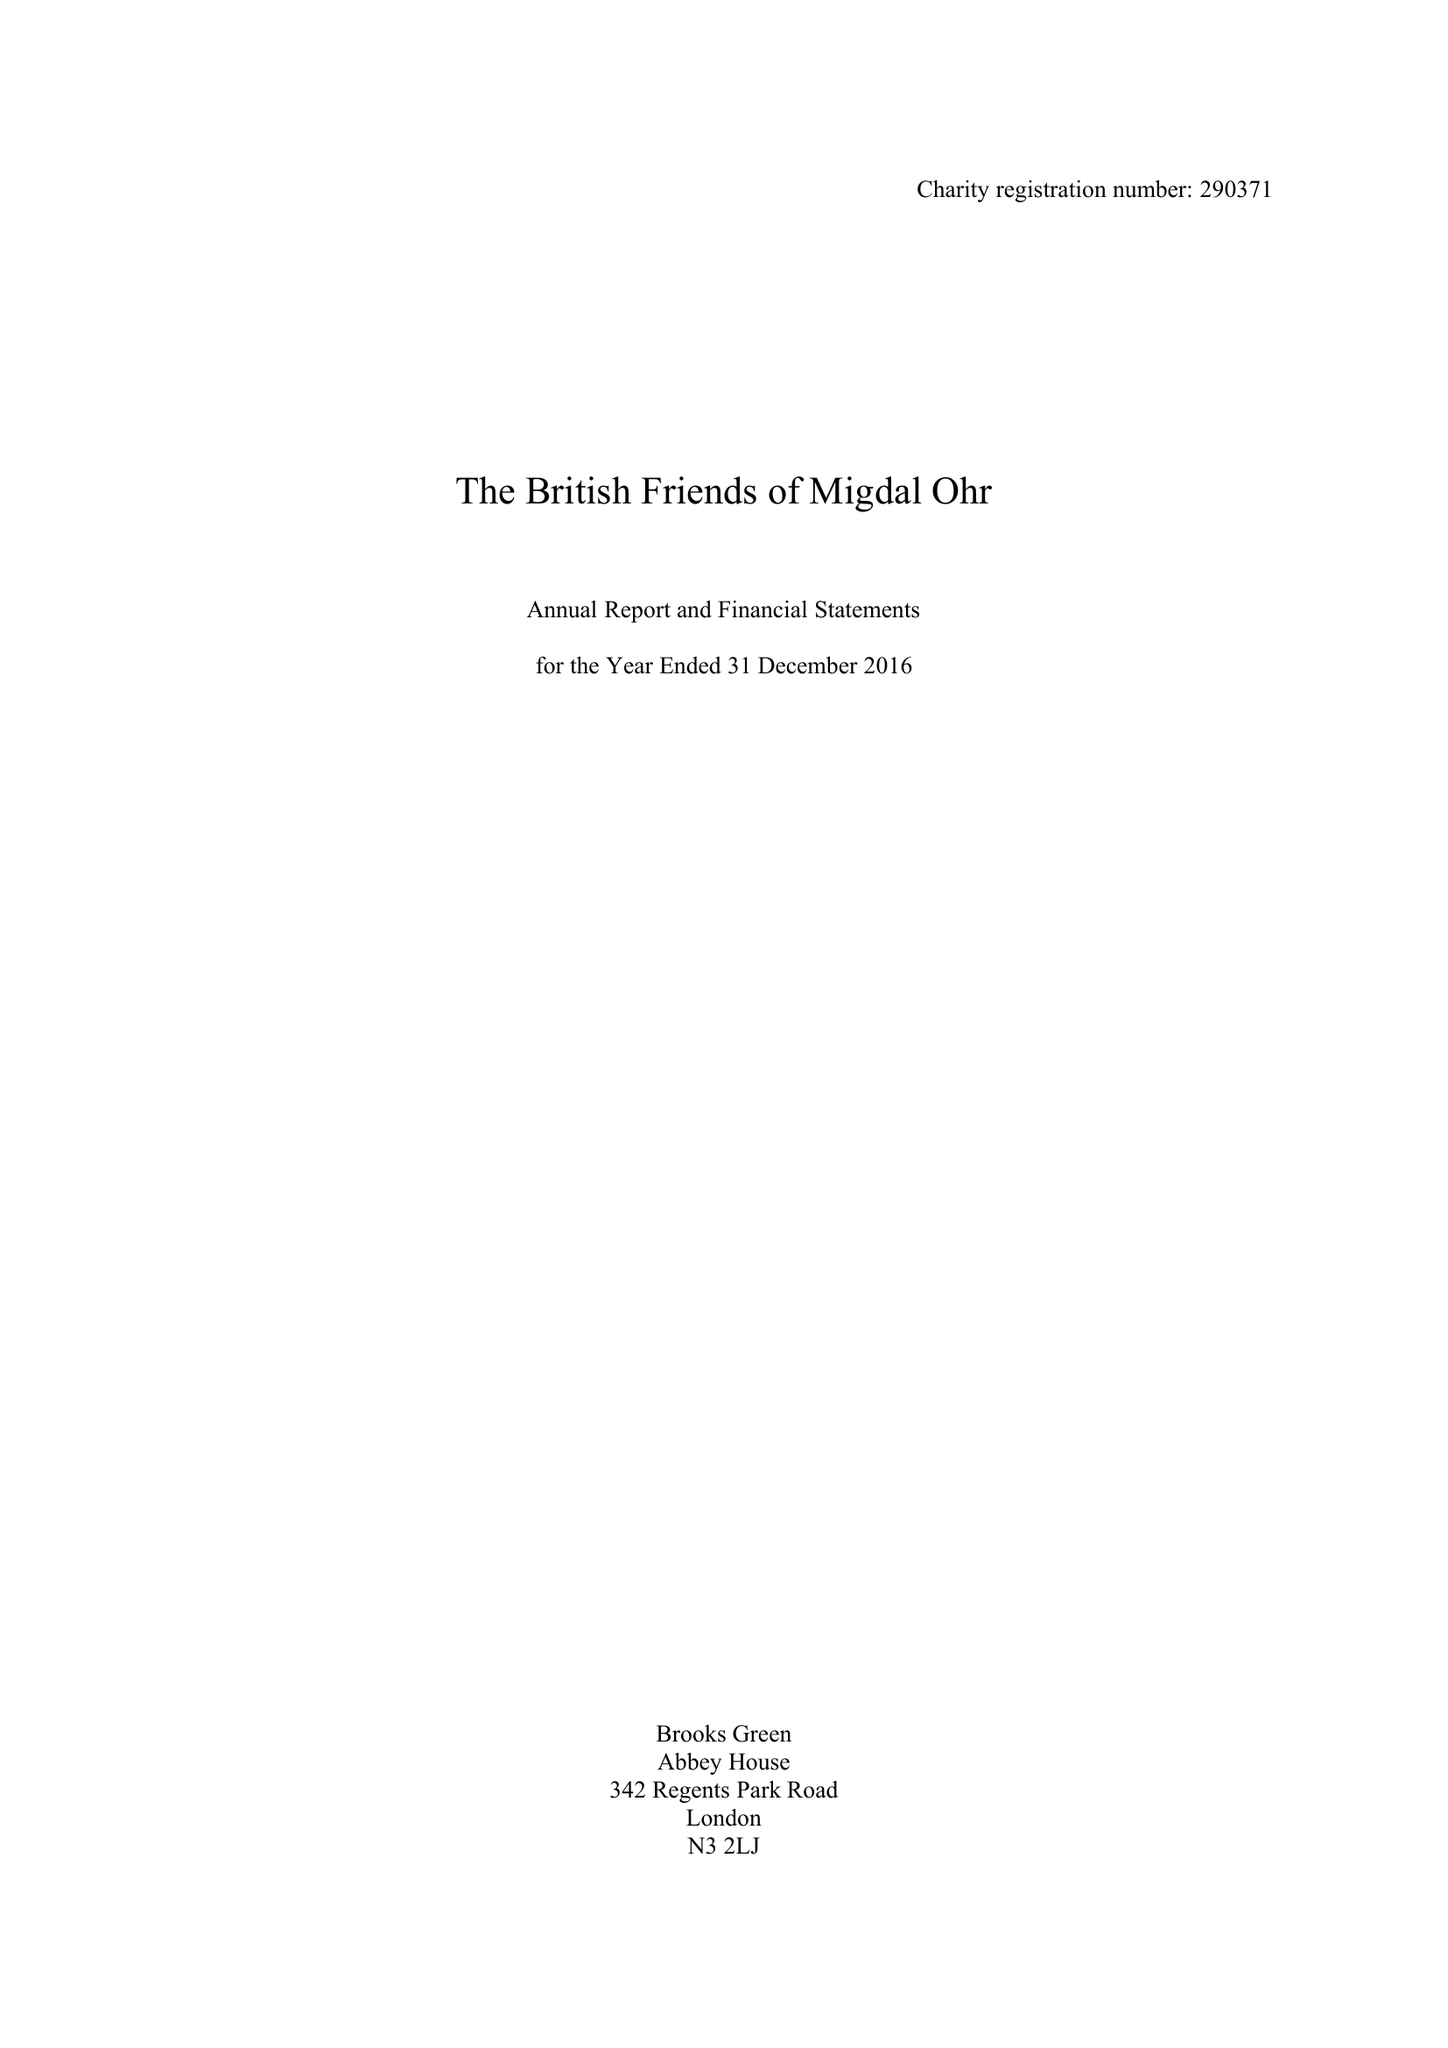What is the value for the spending_annually_in_british_pounds?
Answer the question using a single word or phrase. 699330.00 